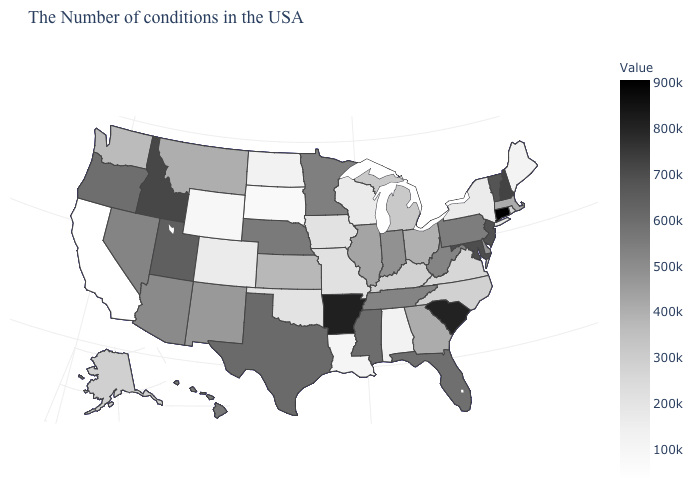Which states have the lowest value in the USA?
Short answer required. California. Which states have the highest value in the USA?
Short answer required. Connecticut. Which states have the highest value in the USA?
Give a very brief answer. Connecticut. Does Missouri have a lower value than South Dakota?
Be succinct. No. Does the map have missing data?
Concise answer only. No. 